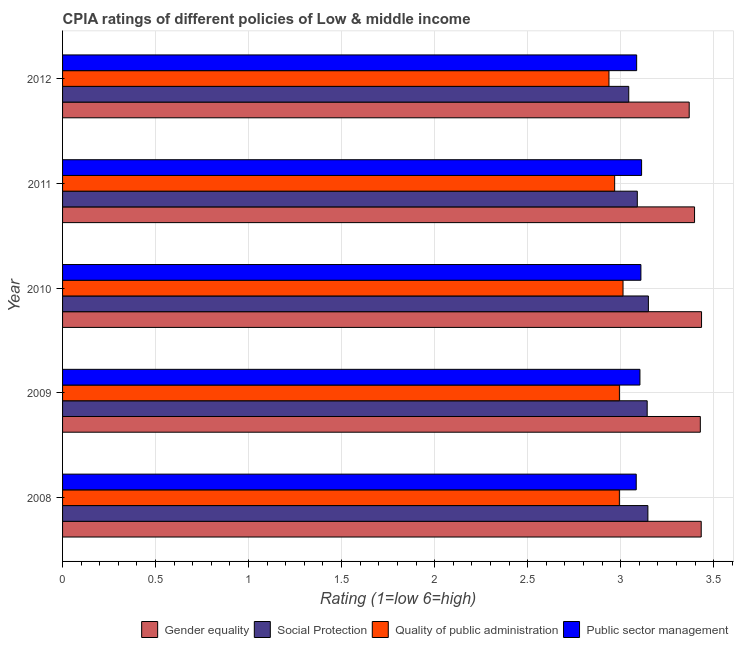How many different coloured bars are there?
Provide a short and direct response. 4. Are the number of bars per tick equal to the number of legend labels?
Your answer should be very brief. Yes. Are the number of bars on each tick of the Y-axis equal?
Provide a short and direct response. Yes. How many bars are there on the 1st tick from the top?
Your answer should be very brief. 4. What is the cpia rating of quality of public administration in 2009?
Provide a succinct answer. 2.99. Across all years, what is the maximum cpia rating of public sector management?
Give a very brief answer. 3.11. Across all years, what is the minimum cpia rating of public sector management?
Your response must be concise. 3.08. In which year was the cpia rating of quality of public administration minimum?
Make the answer very short. 2012. What is the total cpia rating of gender equality in the graph?
Your response must be concise. 17.06. What is the difference between the cpia rating of quality of public administration in 2009 and the cpia rating of social protection in 2010?
Make the answer very short. -0.16. What is the average cpia rating of public sector management per year?
Your response must be concise. 3.1. In the year 2011, what is the difference between the cpia rating of public sector management and cpia rating of social protection?
Your answer should be compact. 0.02. In how many years, is the cpia rating of public sector management greater than 0.6 ?
Provide a short and direct response. 5. Is the cpia rating of public sector management in 2010 less than that in 2012?
Ensure brevity in your answer.  No. What is the difference between the highest and the second highest cpia rating of social protection?
Your answer should be compact. 0. What is the difference between the highest and the lowest cpia rating of gender equality?
Keep it short and to the point. 0.07. In how many years, is the cpia rating of quality of public administration greater than the average cpia rating of quality of public administration taken over all years?
Your answer should be very brief. 3. Is the sum of the cpia rating of public sector management in 2010 and 2012 greater than the maximum cpia rating of social protection across all years?
Ensure brevity in your answer.  Yes. What does the 4th bar from the top in 2012 represents?
Provide a succinct answer. Gender equality. What does the 4th bar from the bottom in 2010 represents?
Provide a succinct answer. Public sector management. Is it the case that in every year, the sum of the cpia rating of gender equality and cpia rating of social protection is greater than the cpia rating of quality of public administration?
Ensure brevity in your answer.  Yes. How many years are there in the graph?
Make the answer very short. 5. Are the values on the major ticks of X-axis written in scientific E-notation?
Keep it short and to the point. No. Does the graph contain any zero values?
Make the answer very short. No. How many legend labels are there?
Provide a short and direct response. 4. How are the legend labels stacked?
Your answer should be compact. Horizontal. What is the title of the graph?
Keep it short and to the point. CPIA ratings of different policies of Low & middle income. What is the label or title of the X-axis?
Your answer should be compact. Rating (1=low 6=high). What is the label or title of the Y-axis?
Your answer should be very brief. Year. What is the Rating (1=low 6=high) of Gender equality in 2008?
Offer a terse response. 3.43. What is the Rating (1=low 6=high) of Social Protection in 2008?
Offer a very short reply. 3.15. What is the Rating (1=low 6=high) of Quality of public administration in 2008?
Provide a succinct answer. 2.99. What is the Rating (1=low 6=high) in Public sector management in 2008?
Your response must be concise. 3.08. What is the Rating (1=low 6=high) in Gender equality in 2009?
Make the answer very short. 3.43. What is the Rating (1=low 6=high) in Social Protection in 2009?
Make the answer very short. 3.14. What is the Rating (1=low 6=high) of Quality of public administration in 2009?
Keep it short and to the point. 2.99. What is the Rating (1=low 6=high) of Public sector management in 2009?
Keep it short and to the point. 3.1. What is the Rating (1=low 6=high) in Gender equality in 2010?
Give a very brief answer. 3.44. What is the Rating (1=low 6=high) of Social Protection in 2010?
Your response must be concise. 3.15. What is the Rating (1=low 6=high) of Quality of public administration in 2010?
Provide a succinct answer. 3.01. What is the Rating (1=low 6=high) in Public sector management in 2010?
Your answer should be compact. 3.11. What is the Rating (1=low 6=high) of Gender equality in 2011?
Make the answer very short. 3.4. What is the Rating (1=low 6=high) of Social Protection in 2011?
Your response must be concise. 3.09. What is the Rating (1=low 6=high) in Quality of public administration in 2011?
Keep it short and to the point. 2.97. What is the Rating (1=low 6=high) of Public sector management in 2011?
Ensure brevity in your answer.  3.11. What is the Rating (1=low 6=high) in Gender equality in 2012?
Your answer should be compact. 3.37. What is the Rating (1=low 6=high) in Social Protection in 2012?
Your answer should be very brief. 3.04. What is the Rating (1=low 6=high) in Quality of public administration in 2012?
Keep it short and to the point. 2.94. What is the Rating (1=low 6=high) of Public sector management in 2012?
Make the answer very short. 3.09. Across all years, what is the maximum Rating (1=low 6=high) of Gender equality?
Give a very brief answer. 3.44. Across all years, what is the maximum Rating (1=low 6=high) of Social Protection?
Offer a terse response. 3.15. Across all years, what is the maximum Rating (1=low 6=high) of Quality of public administration?
Offer a very short reply. 3.01. Across all years, what is the maximum Rating (1=low 6=high) of Public sector management?
Keep it short and to the point. 3.11. Across all years, what is the minimum Rating (1=low 6=high) in Gender equality?
Provide a short and direct response. 3.37. Across all years, what is the minimum Rating (1=low 6=high) of Social Protection?
Provide a short and direct response. 3.04. Across all years, what is the minimum Rating (1=low 6=high) in Quality of public administration?
Offer a terse response. 2.94. Across all years, what is the minimum Rating (1=low 6=high) of Public sector management?
Give a very brief answer. 3.08. What is the total Rating (1=low 6=high) in Gender equality in the graph?
Provide a short and direct response. 17.06. What is the total Rating (1=low 6=high) of Social Protection in the graph?
Ensure brevity in your answer.  15.57. What is the total Rating (1=low 6=high) of Quality of public administration in the graph?
Provide a succinct answer. 14.91. What is the total Rating (1=low 6=high) of Public sector management in the graph?
Your response must be concise. 15.5. What is the difference between the Rating (1=low 6=high) in Gender equality in 2008 and that in 2009?
Offer a terse response. 0. What is the difference between the Rating (1=low 6=high) in Social Protection in 2008 and that in 2009?
Keep it short and to the point. 0. What is the difference between the Rating (1=low 6=high) of Quality of public administration in 2008 and that in 2009?
Your answer should be compact. -0. What is the difference between the Rating (1=low 6=high) in Public sector management in 2008 and that in 2009?
Offer a terse response. -0.02. What is the difference between the Rating (1=low 6=high) of Gender equality in 2008 and that in 2010?
Keep it short and to the point. -0. What is the difference between the Rating (1=low 6=high) of Social Protection in 2008 and that in 2010?
Your answer should be very brief. -0. What is the difference between the Rating (1=low 6=high) in Quality of public administration in 2008 and that in 2010?
Keep it short and to the point. -0.02. What is the difference between the Rating (1=low 6=high) in Public sector management in 2008 and that in 2010?
Keep it short and to the point. -0.03. What is the difference between the Rating (1=low 6=high) in Gender equality in 2008 and that in 2011?
Your response must be concise. 0.04. What is the difference between the Rating (1=low 6=high) of Social Protection in 2008 and that in 2011?
Provide a succinct answer. 0.06. What is the difference between the Rating (1=low 6=high) of Quality of public administration in 2008 and that in 2011?
Ensure brevity in your answer.  0.03. What is the difference between the Rating (1=low 6=high) of Public sector management in 2008 and that in 2011?
Keep it short and to the point. -0.03. What is the difference between the Rating (1=low 6=high) of Gender equality in 2008 and that in 2012?
Your response must be concise. 0.06. What is the difference between the Rating (1=low 6=high) in Social Protection in 2008 and that in 2012?
Provide a short and direct response. 0.1. What is the difference between the Rating (1=low 6=high) in Quality of public administration in 2008 and that in 2012?
Ensure brevity in your answer.  0.06. What is the difference between the Rating (1=low 6=high) of Public sector management in 2008 and that in 2012?
Make the answer very short. -0. What is the difference between the Rating (1=low 6=high) of Gender equality in 2009 and that in 2010?
Ensure brevity in your answer.  -0.01. What is the difference between the Rating (1=low 6=high) in Social Protection in 2009 and that in 2010?
Keep it short and to the point. -0.01. What is the difference between the Rating (1=low 6=high) in Quality of public administration in 2009 and that in 2010?
Your answer should be very brief. -0.02. What is the difference between the Rating (1=low 6=high) of Public sector management in 2009 and that in 2010?
Give a very brief answer. -0.01. What is the difference between the Rating (1=low 6=high) of Gender equality in 2009 and that in 2011?
Your answer should be compact. 0.03. What is the difference between the Rating (1=low 6=high) of Social Protection in 2009 and that in 2011?
Give a very brief answer. 0.05. What is the difference between the Rating (1=low 6=high) of Quality of public administration in 2009 and that in 2011?
Provide a succinct answer. 0.03. What is the difference between the Rating (1=low 6=high) in Public sector management in 2009 and that in 2011?
Offer a terse response. -0.01. What is the difference between the Rating (1=low 6=high) of Gender equality in 2009 and that in 2012?
Your answer should be very brief. 0.06. What is the difference between the Rating (1=low 6=high) in Social Protection in 2009 and that in 2012?
Give a very brief answer. 0.1. What is the difference between the Rating (1=low 6=high) in Quality of public administration in 2009 and that in 2012?
Your answer should be very brief. 0.06. What is the difference between the Rating (1=low 6=high) in Public sector management in 2009 and that in 2012?
Give a very brief answer. 0.02. What is the difference between the Rating (1=low 6=high) of Gender equality in 2010 and that in 2011?
Give a very brief answer. 0.04. What is the difference between the Rating (1=low 6=high) of Social Protection in 2010 and that in 2011?
Ensure brevity in your answer.  0.06. What is the difference between the Rating (1=low 6=high) in Quality of public administration in 2010 and that in 2011?
Provide a short and direct response. 0.04. What is the difference between the Rating (1=low 6=high) of Public sector management in 2010 and that in 2011?
Ensure brevity in your answer.  -0. What is the difference between the Rating (1=low 6=high) of Gender equality in 2010 and that in 2012?
Provide a succinct answer. 0.07. What is the difference between the Rating (1=low 6=high) of Social Protection in 2010 and that in 2012?
Provide a succinct answer. 0.11. What is the difference between the Rating (1=low 6=high) of Quality of public administration in 2010 and that in 2012?
Your response must be concise. 0.08. What is the difference between the Rating (1=low 6=high) of Public sector management in 2010 and that in 2012?
Ensure brevity in your answer.  0.02. What is the difference between the Rating (1=low 6=high) of Gender equality in 2011 and that in 2012?
Offer a terse response. 0.03. What is the difference between the Rating (1=low 6=high) of Social Protection in 2011 and that in 2012?
Give a very brief answer. 0.05. What is the difference between the Rating (1=low 6=high) in Quality of public administration in 2011 and that in 2012?
Provide a succinct answer. 0.03. What is the difference between the Rating (1=low 6=high) of Public sector management in 2011 and that in 2012?
Keep it short and to the point. 0.03. What is the difference between the Rating (1=low 6=high) in Gender equality in 2008 and the Rating (1=low 6=high) in Social Protection in 2009?
Make the answer very short. 0.29. What is the difference between the Rating (1=low 6=high) in Gender equality in 2008 and the Rating (1=low 6=high) in Quality of public administration in 2009?
Give a very brief answer. 0.44. What is the difference between the Rating (1=low 6=high) in Gender equality in 2008 and the Rating (1=low 6=high) in Public sector management in 2009?
Provide a short and direct response. 0.33. What is the difference between the Rating (1=low 6=high) in Social Protection in 2008 and the Rating (1=low 6=high) in Quality of public administration in 2009?
Your response must be concise. 0.15. What is the difference between the Rating (1=low 6=high) in Social Protection in 2008 and the Rating (1=low 6=high) in Public sector management in 2009?
Ensure brevity in your answer.  0.04. What is the difference between the Rating (1=low 6=high) in Quality of public administration in 2008 and the Rating (1=low 6=high) in Public sector management in 2009?
Your answer should be compact. -0.11. What is the difference between the Rating (1=low 6=high) of Gender equality in 2008 and the Rating (1=low 6=high) of Social Protection in 2010?
Offer a terse response. 0.28. What is the difference between the Rating (1=low 6=high) in Gender equality in 2008 and the Rating (1=low 6=high) in Quality of public administration in 2010?
Provide a succinct answer. 0.42. What is the difference between the Rating (1=low 6=high) of Gender equality in 2008 and the Rating (1=low 6=high) of Public sector management in 2010?
Offer a terse response. 0.32. What is the difference between the Rating (1=low 6=high) of Social Protection in 2008 and the Rating (1=low 6=high) of Quality of public administration in 2010?
Keep it short and to the point. 0.13. What is the difference between the Rating (1=low 6=high) in Social Protection in 2008 and the Rating (1=low 6=high) in Public sector management in 2010?
Your response must be concise. 0.04. What is the difference between the Rating (1=low 6=high) of Quality of public administration in 2008 and the Rating (1=low 6=high) of Public sector management in 2010?
Provide a succinct answer. -0.12. What is the difference between the Rating (1=low 6=high) in Gender equality in 2008 and the Rating (1=low 6=high) in Social Protection in 2011?
Offer a very short reply. 0.34. What is the difference between the Rating (1=low 6=high) of Gender equality in 2008 and the Rating (1=low 6=high) of Quality of public administration in 2011?
Provide a short and direct response. 0.47. What is the difference between the Rating (1=low 6=high) of Gender equality in 2008 and the Rating (1=low 6=high) of Public sector management in 2011?
Provide a short and direct response. 0.32. What is the difference between the Rating (1=low 6=high) of Social Protection in 2008 and the Rating (1=low 6=high) of Quality of public administration in 2011?
Give a very brief answer. 0.18. What is the difference between the Rating (1=low 6=high) of Social Protection in 2008 and the Rating (1=low 6=high) of Public sector management in 2011?
Your response must be concise. 0.03. What is the difference between the Rating (1=low 6=high) in Quality of public administration in 2008 and the Rating (1=low 6=high) in Public sector management in 2011?
Provide a succinct answer. -0.12. What is the difference between the Rating (1=low 6=high) of Gender equality in 2008 and the Rating (1=low 6=high) of Social Protection in 2012?
Your answer should be very brief. 0.39. What is the difference between the Rating (1=low 6=high) in Gender equality in 2008 and the Rating (1=low 6=high) in Quality of public administration in 2012?
Your response must be concise. 0.5. What is the difference between the Rating (1=low 6=high) in Gender equality in 2008 and the Rating (1=low 6=high) in Public sector management in 2012?
Ensure brevity in your answer.  0.35. What is the difference between the Rating (1=low 6=high) of Social Protection in 2008 and the Rating (1=low 6=high) of Quality of public administration in 2012?
Your response must be concise. 0.21. What is the difference between the Rating (1=low 6=high) in Social Protection in 2008 and the Rating (1=low 6=high) in Public sector management in 2012?
Provide a succinct answer. 0.06. What is the difference between the Rating (1=low 6=high) in Quality of public administration in 2008 and the Rating (1=low 6=high) in Public sector management in 2012?
Provide a succinct answer. -0.09. What is the difference between the Rating (1=low 6=high) of Gender equality in 2009 and the Rating (1=low 6=high) of Social Protection in 2010?
Keep it short and to the point. 0.28. What is the difference between the Rating (1=low 6=high) of Gender equality in 2009 and the Rating (1=low 6=high) of Quality of public administration in 2010?
Offer a terse response. 0.42. What is the difference between the Rating (1=low 6=high) of Gender equality in 2009 and the Rating (1=low 6=high) of Public sector management in 2010?
Give a very brief answer. 0.32. What is the difference between the Rating (1=low 6=high) in Social Protection in 2009 and the Rating (1=low 6=high) in Quality of public administration in 2010?
Provide a succinct answer. 0.13. What is the difference between the Rating (1=low 6=high) in Social Protection in 2009 and the Rating (1=low 6=high) in Public sector management in 2010?
Offer a very short reply. 0.03. What is the difference between the Rating (1=low 6=high) in Quality of public administration in 2009 and the Rating (1=low 6=high) in Public sector management in 2010?
Your response must be concise. -0.12. What is the difference between the Rating (1=low 6=high) in Gender equality in 2009 and the Rating (1=low 6=high) in Social Protection in 2011?
Keep it short and to the point. 0.34. What is the difference between the Rating (1=low 6=high) in Gender equality in 2009 and the Rating (1=low 6=high) in Quality of public administration in 2011?
Give a very brief answer. 0.46. What is the difference between the Rating (1=low 6=high) of Gender equality in 2009 and the Rating (1=low 6=high) of Public sector management in 2011?
Ensure brevity in your answer.  0.32. What is the difference between the Rating (1=low 6=high) of Social Protection in 2009 and the Rating (1=low 6=high) of Quality of public administration in 2011?
Ensure brevity in your answer.  0.17. What is the difference between the Rating (1=low 6=high) in Quality of public administration in 2009 and the Rating (1=low 6=high) in Public sector management in 2011?
Keep it short and to the point. -0.12. What is the difference between the Rating (1=low 6=high) in Gender equality in 2009 and the Rating (1=low 6=high) in Social Protection in 2012?
Your response must be concise. 0.38. What is the difference between the Rating (1=low 6=high) of Gender equality in 2009 and the Rating (1=low 6=high) of Quality of public administration in 2012?
Provide a succinct answer. 0.49. What is the difference between the Rating (1=low 6=high) in Gender equality in 2009 and the Rating (1=low 6=high) in Public sector management in 2012?
Offer a very short reply. 0.34. What is the difference between the Rating (1=low 6=high) in Social Protection in 2009 and the Rating (1=low 6=high) in Quality of public administration in 2012?
Give a very brief answer. 0.21. What is the difference between the Rating (1=low 6=high) of Social Protection in 2009 and the Rating (1=low 6=high) of Public sector management in 2012?
Your answer should be very brief. 0.06. What is the difference between the Rating (1=low 6=high) in Quality of public administration in 2009 and the Rating (1=low 6=high) in Public sector management in 2012?
Ensure brevity in your answer.  -0.09. What is the difference between the Rating (1=low 6=high) in Gender equality in 2010 and the Rating (1=low 6=high) in Social Protection in 2011?
Your answer should be compact. 0.35. What is the difference between the Rating (1=low 6=high) of Gender equality in 2010 and the Rating (1=low 6=high) of Quality of public administration in 2011?
Ensure brevity in your answer.  0.47. What is the difference between the Rating (1=low 6=high) in Gender equality in 2010 and the Rating (1=low 6=high) in Public sector management in 2011?
Ensure brevity in your answer.  0.32. What is the difference between the Rating (1=low 6=high) in Social Protection in 2010 and the Rating (1=low 6=high) in Quality of public administration in 2011?
Provide a succinct answer. 0.18. What is the difference between the Rating (1=low 6=high) in Social Protection in 2010 and the Rating (1=low 6=high) in Public sector management in 2011?
Provide a short and direct response. 0.04. What is the difference between the Rating (1=low 6=high) in Quality of public administration in 2010 and the Rating (1=low 6=high) in Public sector management in 2011?
Offer a very short reply. -0.1. What is the difference between the Rating (1=low 6=high) in Gender equality in 2010 and the Rating (1=low 6=high) in Social Protection in 2012?
Your answer should be compact. 0.39. What is the difference between the Rating (1=low 6=high) of Gender equality in 2010 and the Rating (1=low 6=high) of Quality of public administration in 2012?
Provide a short and direct response. 0.5. What is the difference between the Rating (1=low 6=high) of Gender equality in 2010 and the Rating (1=low 6=high) of Public sector management in 2012?
Offer a terse response. 0.35. What is the difference between the Rating (1=low 6=high) in Social Protection in 2010 and the Rating (1=low 6=high) in Quality of public administration in 2012?
Your answer should be very brief. 0.21. What is the difference between the Rating (1=low 6=high) in Social Protection in 2010 and the Rating (1=low 6=high) in Public sector management in 2012?
Make the answer very short. 0.06. What is the difference between the Rating (1=low 6=high) in Quality of public administration in 2010 and the Rating (1=low 6=high) in Public sector management in 2012?
Your answer should be very brief. -0.07. What is the difference between the Rating (1=low 6=high) of Gender equality in 2011 and the Rating (1=low 6=high) of Social Protection in 2012?
Your answer should be compact. 0.35. What is the difference between the Rating (1=low 6=high) of Gender equality in 2011 and the Rating (1=low 6=high) of Quality of public administration in 2012?
Keep it short and to the point. 0.46. What is the difference between the Rating (1=low 6=high) in Gender equality in 2011 and the Rating (1=low 6=high) in Public sector management in 2012?
Offer a very short reply. 0.31. What is the difference between the Rating (1=low 6=high) of Social Protection in 2011 and the Rating (1=low 6=high) of Quality of public administration in 2012?
Provide a succinct answer. 0.15. What is the difference between the Rating (1=low 6=high) in Social Protection in 2011 and the Rating (1=low 6=high) in Public sector management in 2012?
Ensure brevity in your answer.  0. What is the difference between the Rating (1=low 6=high) of Quality of public administration in 2011 and the Rating (1=low 6=high) of Public sector management in 2012?
Give a very brief answer. -0.12. What is the average Rating (1=low 6=high) in Gender equality per year?
Provide a short and direct response. 3.41. What is the average Rating (1=low 6=high) of Social Protection per year?
Make the answer very short. 3.11. What is the average Rating (1=low 6=high) of Quality of public administration per year?
Offer a very short reply. 2.98. What is the average Rating (1=low 6=high) of Public sector management per year?
Keep it short and to the point. 3.1. In the year 2008, what is the difference between the Rating (1=low 6=high) of Gender equality and Rating (1=low 6=high) of Social Protection?
Your answer should be very brief. 0.29. In the year 2008, what is the difference between the Rating (1=low 6=high) in Gender equality and Rating (1=low 6=high) in Quality of public administration?
Provide a short and direct response. 0.44. In the year 2008, what is the difference between the Rating (1=low 6=high) in Gender equality and Rating (1=low 6=high) in Public sector management?
Make the answer very short. 0.35. In the year 2008, what is the difference between the Rating (1=low 6=high) of Social Protection and Rating (1=low 6=high) of Quality of public administration?
Your response must be concise. 0.15. In the year 2008, what is the difference between the Rating (1=low 6=high) in Social Protection and Rating (1=low 6=high) in Public sector management?
Offer a terse response. 0.06. In the year 2008, what is the difference between the Rating (1=low 6=high) of Quality of public administration and Rating (1=low 6=high) of Public sector management?
Keep it short and to the point. -0.09. In the year 2009, what is the difference between the Rating (1=low 6=high) of Gender equality and Rating (1=low 6=high) of Social Protection?
Offer a very short reply. 0.29. In the year 2009, what is the difference between the Rating (1=low 6=high) in Gender equality and Rating (1=low 6=high) in Quality of public administration?
Offer a very short reply. 0.44. In the year 2009, what is the difference between the Rating (1=low 6=high) in Gender equality and Rating (1=low 6=high) in Public sector management?
Ensure brevity in your answer.  0.32. In the year 2009, what is the difference between the Rating (1=low 6=high) in Social Protection and Rating (1=low 6=high) in Quality of public administration?
Keep it short and to the point. 0.15. In the year 2009, what is the difference between the Rating (1=low 6=high) of Social Protection and Rating (1=low 6=high) of Public sector management?
Give a very brief answer. 0.04. In the year 2009, what is the difference between the Rating (1=low 6=high) in Quality of public administration and Rating (1=low 6=high) in Public sector management?
Ensure brevity in your answer.  -0.11. In the year 2010, what is the difference between the Rating (1=low 6=high) of Gender equality and Rating (1=low 6=high) of Social Protection?
Make the answer very short. 0.29. In the year 2010, what is the difference between the Rating (1=low 6=high) in Gender equality and Rating (1=low 6=high) in Quality of public administration?
Your answer should be very brief. 0.42. In the year 2010, what is the difference between the Rating (1=low 6=high) of Gender equality and Rating (1=low 6=high) of Public sector management?
Offer a terse response. 0.33. In the year 2010, what is the difference between the Rating (1=low 6=high) in Social Protection and Rating (1=low 6=high) in Quality of public administration?
Offer a terse response. 0.14. In the year 2010, what is the difference between the Rating (1=low 6=high) in Social Protection and Rating (1=low 6=high) in Public sector management?
Provide a short and direct response. 0.04. In the year 2010, what is the difference between the Rating (1=low 6=high) in Quality of public administration and Rating (1=low 6=high) in Public sector management?
Provide a succinct answer. -0.1. In the year 2011, what is the difference between the Rating (1=low 6=high) of Gender equality and Rating (1=low 6=high) of Social Protection?
Ensure brevity in your answer.  0.31. In the year 2011, what is the difference between the Rating (1=low 6=high) in Gender equality and Rating (1=low 6=high) in Quality of public administration?
Provide a succinct answer. 0.43. In the year 2011, what is the difference between the Rating (1=low 6=high) of Gender equality and Rating (1=low 6=high) of Public sector management?
Provide a short and direct response. 0.28. In the year 2011, what is the difference between the Rating (1=low 6=high) in Social Protection and Rating (1=low 6=high) in Quality of public administration?
Provide a short and direct response. 0.12. In the year 2011, what is the difference between the Rating (1=low 6=high) in Social Protection and Rating (1=low 6=high) in Public sector management?
Provide a succinct answer. -0.02. In the year 2011, what is the difference between the Rating (1=low 6=high) in Quality of public administration and Rating (1=low 6=high) in Public sector management?
Make the answer very short. -0.14. In the year 2012, what is the difference between the Rating (1=low 6=high) of Gender equality and Rating (1=low 6=high) of Social Protection?
Offer a terse response. 0.33. In the year 2012, what is the difference between the Rating (1=low 6=high) in Gender equality and Rating (1=low 6=high) in Quality of public administration?
Give a very brief answer. 0.43. In the year 2012, what is the difference between the Rating (1=low 6=high) of Gender equality and Rating (1=low 6=high) of Public sector management?
Offer a terse response. 0.28. In the year 2012, what is the difference between the Rating (1=low 6=high) of Social Protection and Rating (1=low 6=high) of Quality of public administration?
Offer a very short reply. 0.11. In the year 2012, what is the difference between the Rating (1=low 6=high) in Social Protection and Rating (1=low 6=high) in Public sector management?
Your response must be concise. -0.04. In the year 2012, what is the difference between the Rating (1=low 6=high) of Quality of public administration and Rating (1=low 6=high) of Public sector management?
Provide a succinct answer. -0.15. What is the ratio of the Rating (1=low 6=high) of Public sector management in 2008 to that in 2010?
Ensure brevity in your answer.  0.99. What is the ratio of the Rating (1=low 6=high) in Gender equality in 2008 to that in 2011?
Your answer should be compact. 1.01. What is the ratio of the Rating (1=low 6=high) of Social Protection in 2008 to that in 2011?
Provide a short and direct response. 1.02. What is the ratio of the Rating (1=low 6=high) of Quality of public administration in 2008 to that in 2011?
Your answer should be compact. 1.01. What is the ratio of the Rating (1=low 6=high) of Gender equality in 2008 to that in 2012?
Keep it short and to the point. 1.02. What is the ratio of the Rating (1=low 6=high) in Social Protection in 2008 to that in 2012?
Give a very brief answer. 1.03. What is the ratio of the Rating (1=low 6=high) in Quality of public administration in 2008 to that in 2012?
Keep it short and to the point. 1.02. What is the ratio of the Rating (1=low 6=high) in Gender equality in 2009 to that in 2010?
Keep it short and to the point. 1. What is the ratio of the Rating (1=low 6=high) in Social Protection in 2009 to that in 2010?
Ensure brevity in your answer.  1. What is the ratio of the Rating (1=low 6=high) in Gender equality in 2009 to that in 2011?
Your response must be concise. 1.01. What is the ratio of the Rating (1=low 6=high) of Social Protection in 2009 to that in 2011?
Your response must be concise. 1.02. What is the ratio of the Rating (1=low 6=high) in Quality of public administration in 2009 to that in 2011?
Ensure brevity in your answer.  1.01. What is the ratio of the Rating (1=low 6=high) of Public sector management in 2009 to that in 2011?
Provide a succinct answer. 1. What is the ratio of the Rating (1=low 6=high) of Gender equality in 2009 to that in 2012?
Ensure brevity in your answer.  1.02. What is the ratio of the Rating (1=low 6=high) of Social Protection in 2009 to that in 2012?
Provide a succinct answer. 1.03. What is the ratio of the Rating (1=low 6=high) of Quality of public administration in 2009 to that in 2012?
Your answer should be very brief. 1.02. What is the ratio of the Rating (1=low 6=high) of Gender equality in 2010 to that in 2011?
Ensure brevity in your answer.  1.01. What is the ratio of the Rating (1=low 6=high) of Social Protection in 2010 to that in 2011?
Ensure brevity in your answer.  1.02. What is the ratio of the Rating (1=low 6=high) in Quality of public administration in 2010 to that in 2011?
Offer a very short reply. 1.02. What is the ratio of the Rating (1=low 6=high) of Gender equality in 2010 to that in 2012?
Your answer should be very brief. 1.02. What is the ratio of the Rating (1=low 6=high) of Social Protection in 2010 to that in 2012?
Your response must be concise. 1.03. What is the ratio of the Rating (1=low 6=high) of Quality of public administration in 2010 to that in 2012?
Your answer should be compact. 1.03. What is the ratio of the Rating (1=low 6=high) in Public sector management in 2010 to that in 2012?
Your answer should be very brief. 1.01. What is the ratio of the Rating (1=low 6=high) of Gender equality in 2011 to that in 2012?
Ensure brevity in your answer.  1.01. What is the ratio of the Rating (1=low 6=high) in Social Protection in 2011 to that in 2012?
Offer a terse response. 1.02. What is the ratio of the Rating (1=low 6=high) in Quality of public administration in 2011 to that in 2012?
Ensure brevity in your answer.  1.01. What is the ratio of the Rating (1=low 6=high) of Public sector management in 2011 to that in 2012?
Provide a short and direct response. 1.01. What is the difference between the highest and the second highest Rating (1=low 6=high) in Gender equality?
Provide a short and direct response. 0. What is the difference between the highest and the second highest Rating (1=low 6=high) in Social Protection?
Provide a succinct answer. 0. What is the difference between the highest and the second highest Rating (1=low 6=high) of Quality of public administration?
Ensure brevity in your answer.  0.02. What is the difference between the highest and the second highest Rating (1=low 6=high) in Public sector management?
Provide a succinct answer. 0. What is the difference between the highest and the lowest Rating (1=low 6=high) in Gender equality?
Your answer should be very brief. 0.07. What is the difference between the highest and the lowest Rating (1=low 6=high) of Social Protection?
Ensure brevity in your answer.  0.11. What is the difference between the highest and the lowest Rating (1=low 6=high) of Quality of public administration?
Provide a short and direct response. 0.08. What is the difference between the highest and the lowest Rating (1=low 6=high) of Public sector management?
Provide a short and direct response. 0.03. 